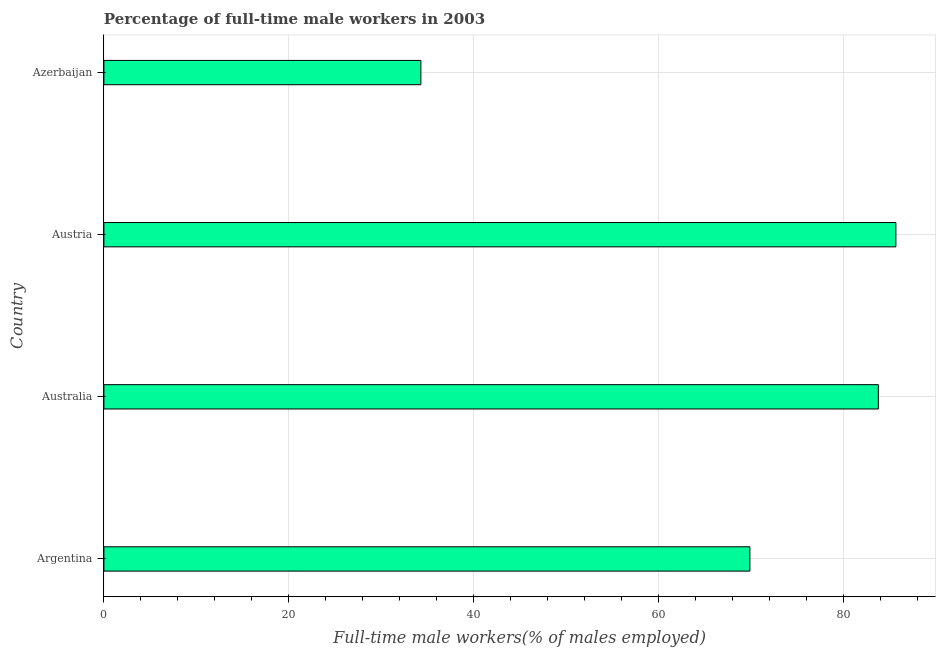Does the graph contain any zero values?
Offer a very short reply. No. Does the graph contain grids?
Your answer should be very brief. Yes. What is the title of the graph?
Provide a succinct answer. Percentage of full-time male workers in 2003. What is the label or title of the X-axis?
Make the answer very short. Full-time male workers(% of males employed). What is the percentage of full-time male workers in Australia?
Keep it short and to the point. 83.8. Across all countries, what is the maximum percentage of full-time male workers?
Make the answer very short. 85.7. Across all countries, what is the minimum percentage of full-time male workers?
Offer a very short reply. 34.3. In which country was the percentage of full-time male workers minimum?
Keep it short and to the point. Azerbaijan. What is the sum of the percentage of full-time male workers?
Keep it short and to the point. 273.7. What is the difference between the percentage of full-time male workers in Argentina and Australia?
Keep it short and to the point. -13.9. What is the average percentage of full-time male workers per country?
Offer a very short reply. 68.42. What is the median percentage of full-time male workers?
Provide a short and direct response. 76.85. What is the ratio of the percentage of full-time male workers in Argentina to that in Azerbaijan?
Provide a succinct answer. 2.04. What is the difference between the highest and the second highest percentage of full-time male workers?
Provide a succinct answer. 1.9. What is the difference between the highest and the lowest percentage of full-time male workers?
Your answer should be compact. 51.4. How many bars are there?
Provide a short and direct response. 4. Are all the bars in the graph horizontal?
Ensure brevity in your answer.  Yes. What is the difference between two consecutive major ticks on the X-axis?
Give a very brief answer. 20. Are the values on the major ticks of X-axis written in scientific E-notation?
Provide a short and direct response. No. What is the Full-time male workers(% of males employed) in Argentina?
Your answer should be compact. 69.9. What is the Full-time male workers(% of males employed) of Australia?
Make the answer very short. 83.8. What is the Full-time male workers(% of males employed) of Austria?
Your response must be concise. 85.7. What is the Full-time male workers(% of males employed) of Azerbaijan?
Provide a short and direct response. 34.3. What is the difference between the Full-time male workers(% of males employed) in Argentina and Austria?
Your response must be concise. -15.8. What is the difference between the Full-time male workers(% of males employed) in Argentina and Azerbaijan?
Make the answer very short. 35.6. What is the difference between the Full-time male workers(% of males employed) in Australia and Austria?
Your answer should be compact. -1.9. What is the difference between the Full-time male workers(% of males employed) in Australia and Azerbaijan?
Keep it short and to the point. 49.5. What is the difference between the Full-time male workers(% of males employed) in Austria and Azerbaijan?
Give a very brief answer. 51.4. What is the ratio of the Full-time male workers(% of males employed) in Argentina to that in Australia?
Ensure brevity in your answer.  0.83. What is the ratio of the Full-time male workers(% of males employed) in Argentina to that in Austria?
Your answer should be compact. 0.82. What is the ratio of the Full-time male workers(% of males employed) in Argentina to that in Azerbaijan?
Your answer should be compact. 2.04. What is the ratio of the Full-time male workers(% of males employed) in Australia to that in Austria?
Offer a very short reply. 0.98. What is the ratio of the Full-time male workers(% of males employed) in Australia to that in Azerbaijan?
Offer a terse response. 2.44. What is the ratio of the Full-time male workers(% of males employed) in Austria to that in Azerbaijan?
Your answer should be compact. 2.5. 